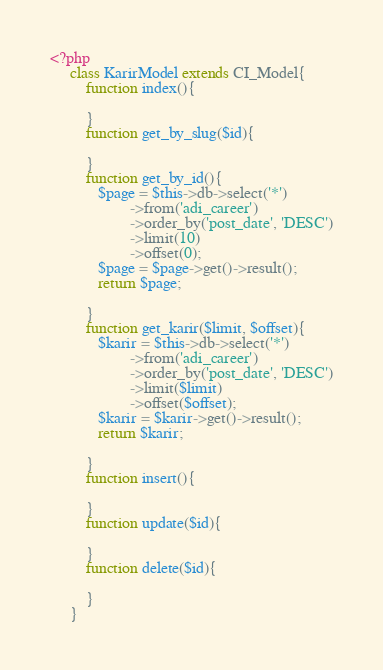Convert code to text. <code><loc_0><loc_0><loc_500><loc_500><_PHP_><?php
     class KarirModel extends CI_Model{
         function index(){

         }
         function get_by_slug($id){

         }
         function get_by_id(){
            $page = $this->db->select('*')
                    ->from('adi_career')
                    ->order_by('post_date', 'DESC')
                    ->limit(10)
                    ->offset(0);
            $page = $page->get()->result();
            return $page;

         }
         function get_karir($limit, $offset){
            $karir = $this->db->select('*')
                    ->from('adi_career')
                    ->order_by('post_date', 'DESC')
                    ->limit($limit)
                    ->offset($offset);
            $karir = $karir->get()->result();
            return $karir;

         }
         function insert(){

         }
         function update($id){

         }
         function delete($id){

         }
     }</code> 